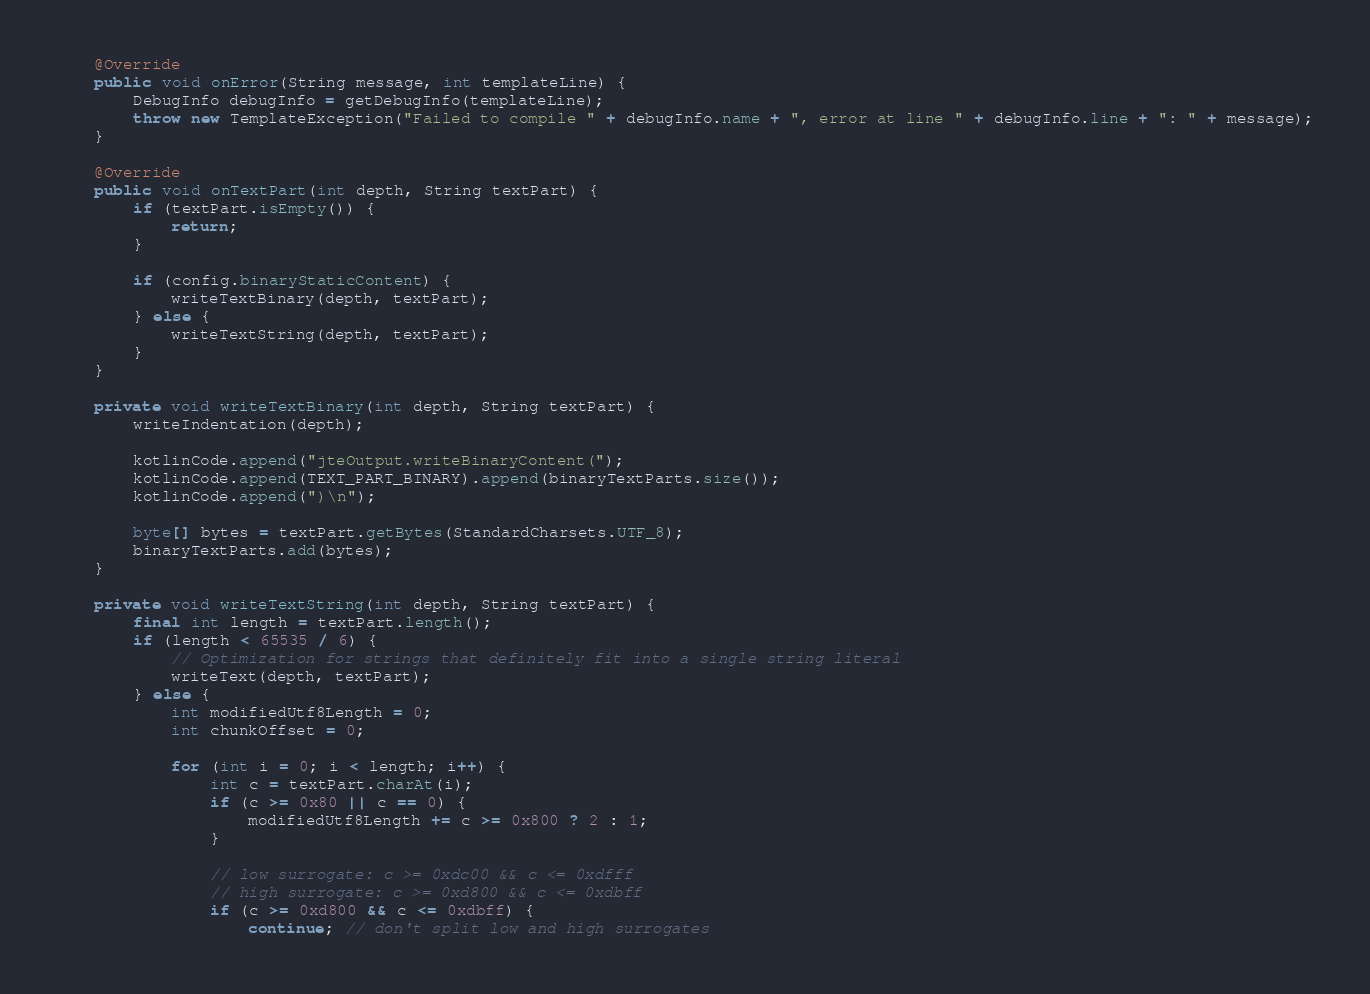<code> <loc_0><loc_0><loc_500><loc_500><_Java_>
    @Override
    public void onError(String message, int templateLine) {
        DebugInfo debugInfo = getDebugInfo(templateLine);
        throw new TemplateException("Failed to compile " + debugInfo.name + ", error at line " + debugInfo.line + ": " + message);
    }

    @Override
    public void onTextPart(int depth, String textPart) {
        if (textPart.isEmpty()) {
            return;
        }

        if (config.binaryStaticContent) {
            writeTextBinary(depth, textPart);
        } else {
            writeTextString(depth, textPart);
        }
    }

    private void writeTextBinary(int depth, String textPart) {
        writeIndentation(depth);

        kotlinCode.append("jteOutput.writeBinaryContent(");
        kotlinCode.append(TEXT_PART_BINARY).append(binaryTextParts.size());
        kotlinCode.append(")\n");

        byte[] bytes = textPart.getBytes(StandardCharsets.UTF_8);
        binaryTextParts.add(bytes);
    }

    private void writeTextString(int depth, String textPart) {
        final int length = textPart.length();
        if (length < 65535 / 6) {
            // Optimization for strings that definitely fit into a single string literal
            writeText(depth, textPart);
        } else {
            int modifiedUtf8Length = 0;
            int chunkOffset = 0;

            for (int i = 0; i < length; i++) {
                int c = textPart.charAt(i);
                if (c >= 0x80 || c == 0) {
                    modifiedUtf8Length += c >= 0x800 ? 2 : 1;
                }

                // low surrogate: c >= 0xdc00 && c <= 0xdfff
                // high surrogate: c >= 0xd800 && c <= 0xdbff
                if (c >= 0xd800 && c <= 0xdbff) {
                    continue; // don't split low and high surrogates</code> 